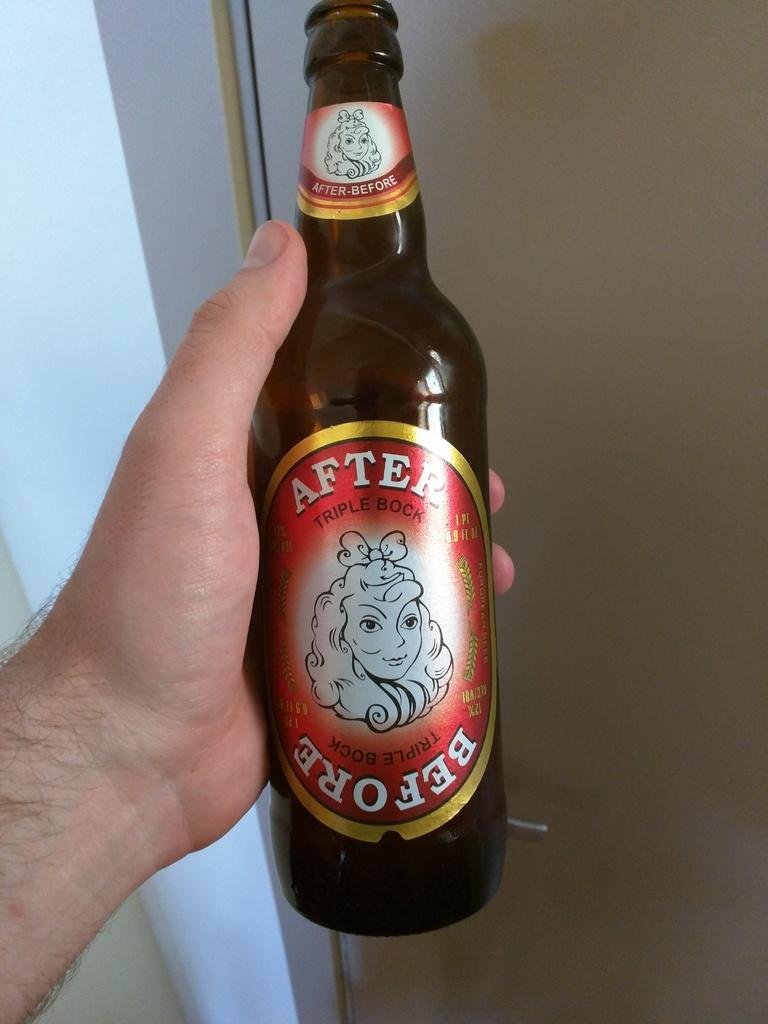Provide a one-sentence caption for the provided image. a bottle of beer with the word After written on the top. 